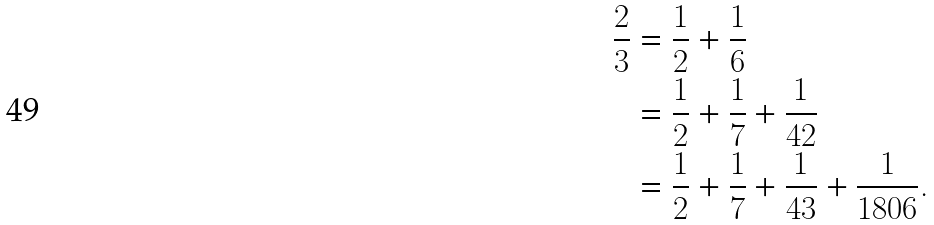Convert formula to latex. <formula><loc_0><loc_0><loc_500><loc_500>\frac { 2 } { 3 } & = \frac { 1 } { 2 } + \frac { 1 } { 6 } \\ & = \frac { 1 } { 2 } + \frac { 1 } { 7 } + \frac { 1 } { 4 2 } \\ & = \frac { 1 } { 2 } + \frac { 1 } { 7 } + \frac { 1 } { 4 3 } + \frac { 1 } { 1 8 0 6 } .</formula> 